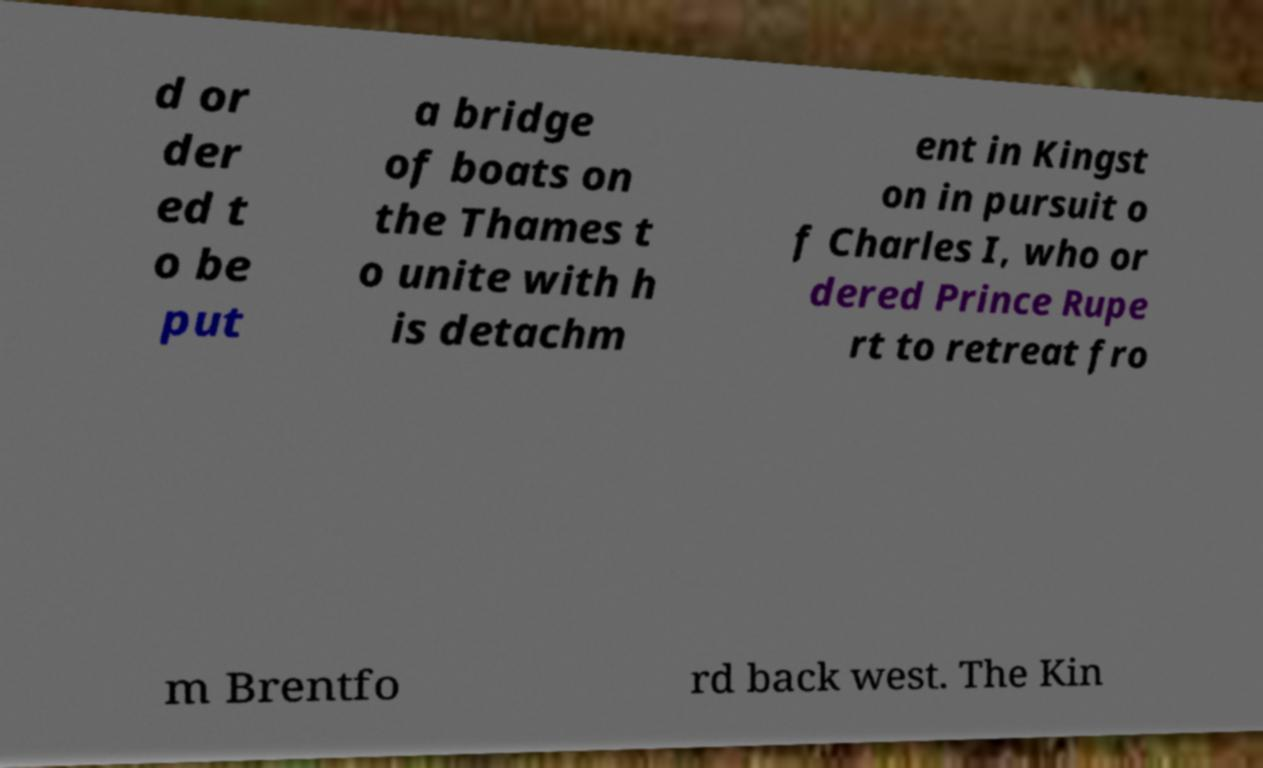Please identify and transcribe the text found in this image. d or der ed t o be put a bridge of boats on the Thames t o unite with h is detachm ent in Kingst on in pursuit o f Charles I, who or dered Prince Rupe rt to retreat fro m Brentfo rd back west. The Kin 